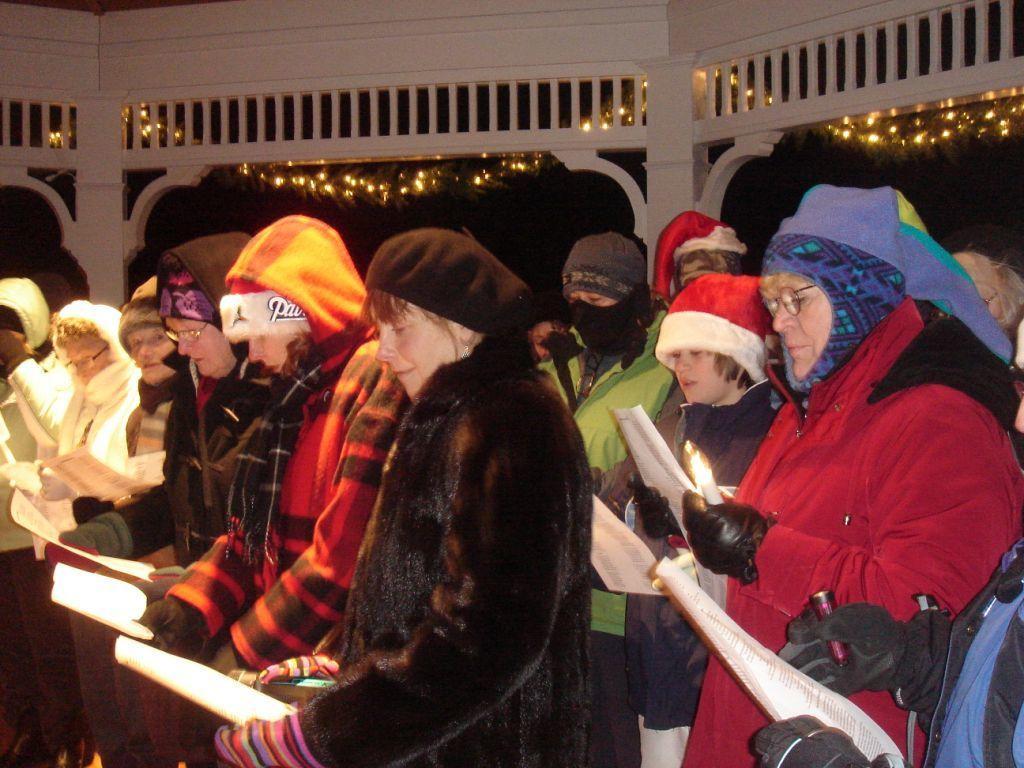In one or two sentences, can you explain what this image depicts? In this picture I can observe people. They are holding papers in their hands. There are men and women in this picture. The background is dark. 